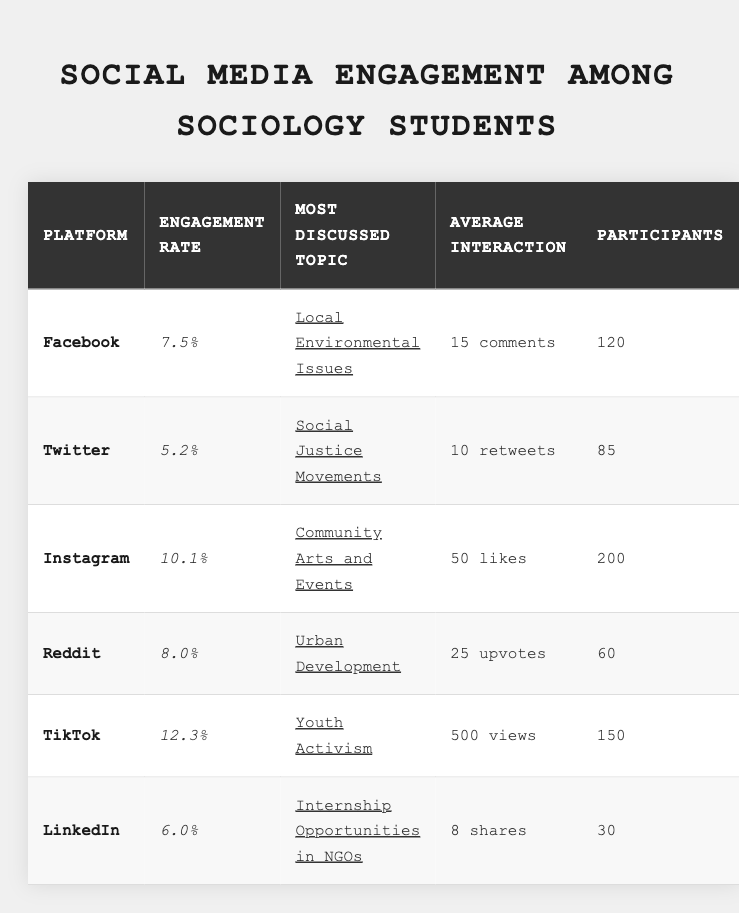What is the highest engagement rate among the platforms? By reviewing the engagement rates listed for each platform, TikTok has the highest engagement rate at 12.3%.
Answer: 12.3% Which platform had the most participants? The participant counts show that Instagram had the most participants with 200.
Answer: 200 What is the average number of comments on Facebook? The table specifies that Facebook had an average of 15 comments.
Answer: 15 How many more participants were on Instagram compared to LinkedIn? The participant counts indicate Instagram had 200 participants, while LinkedIn had 30. The difference is 200 - 30 = 170.
Answer: 170 Which platform had the lowest engagement rate? A comparison of the engagement rates reveals that Twitter had the lowest engagement rate at 5.2%.
Answer: 5.2% Is the most discussed topic on Reddit Urban Development? According to the table, the most discussed topic on Reddit is Urban Development, confirming the statement is true.
Answer: Yes What is the total engagement across all platforms based on the average interactions provided? Adding the average interactions: 15 (Facebook) + 10 (Twitter) + 50 (Instagram) + 25 (Reddit) + 500 (TikTok) + 8 (LinkedIn) gives a total of 608.
Answer: 608 How does the engagement rate correlate with the number of participants? This requires examining each platform's engagement rate alongside its participant count to determine if higher participant counts often correspond with higher engagement rates, which can vary across the platforms. Therefore, there is no direct correlation that can be generalized.
Answer: N/A Which platform had the most likes on average? The data shows that Instagram had the highest average likes at 50.
Answer: 50 What proportion of participants on TikTok engaged in Youth Activism compared to Twitter's discussions on Social Justice Movements? Calculating the proportion involves comparing the number of participants on TikTok (150) to those on Twitter (85): 150 / 85 gives approximately 1.76, indicating that there are about 1.76 times more participants engaging on TikTok.
Answer: 1.76 